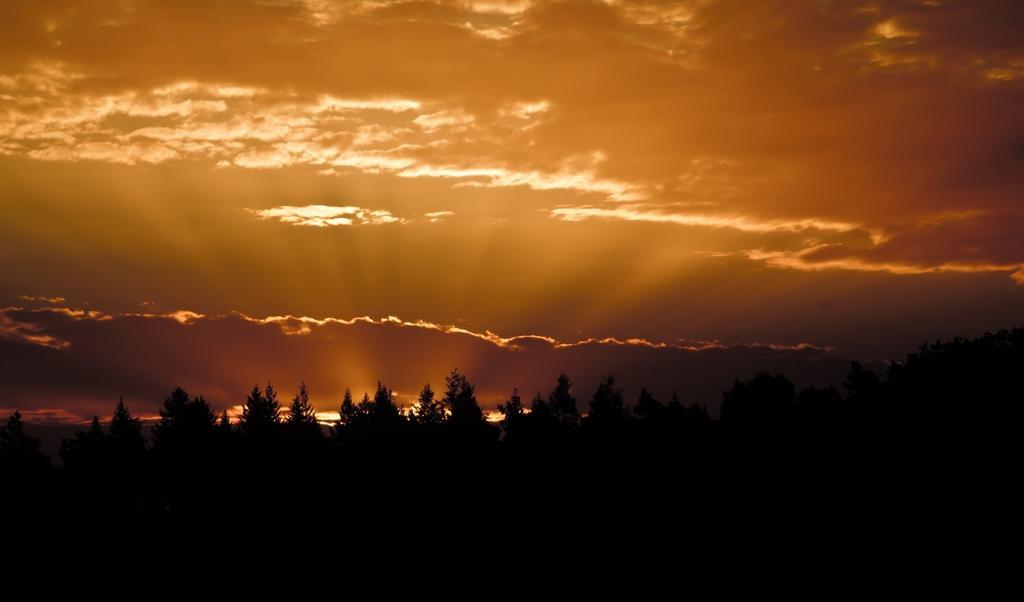Could you give a brief overview of what you see in this image? In this image there is the sky towards the top of the image, there are clouds in the sky, there are trees. 